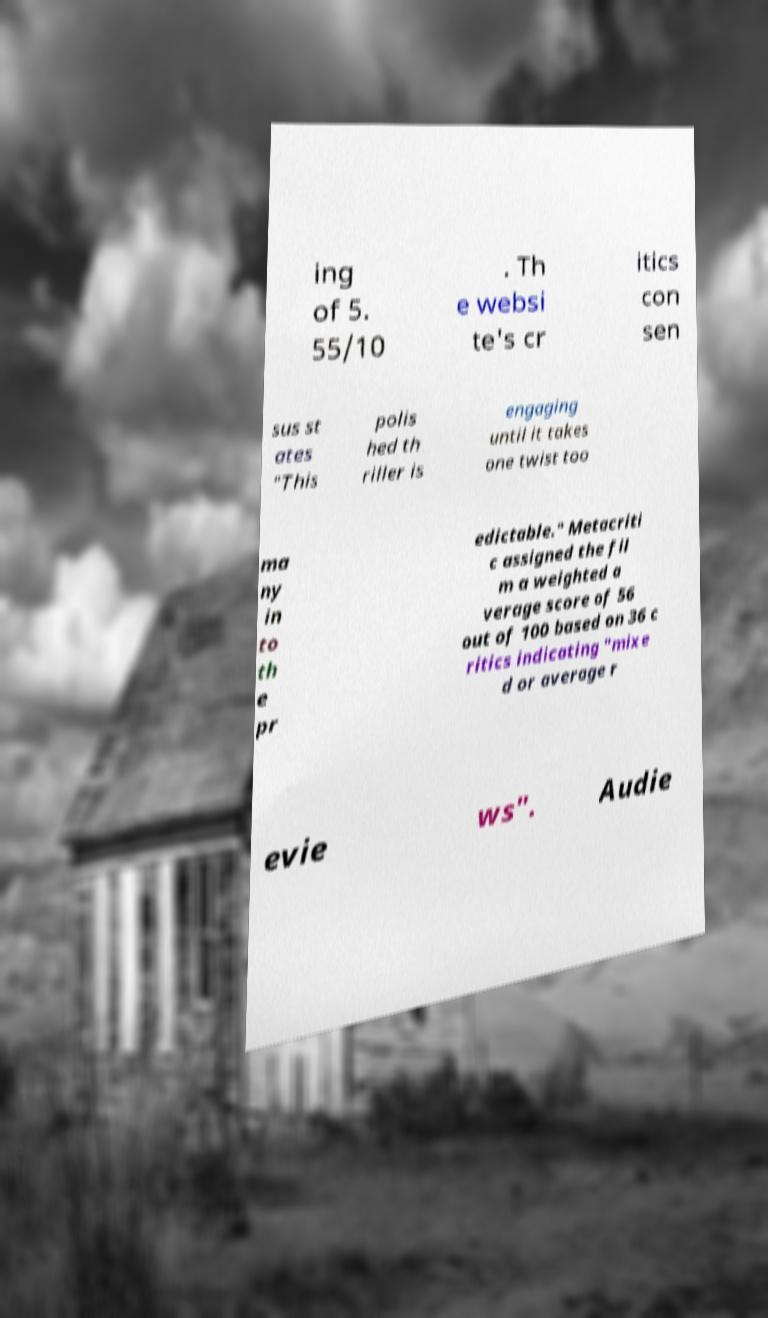There's text embedded in this image that I need extracted. Can you transcribe it verbatim? ing of 5. 55/10 . Th e websi te's cr itics con sen sus st ates "This polis hed th riller is engaging until it takes one twist too ma ny in to th e pr edictable." Metacriti c assigned the fil m a weighted a verage score of 56 out of 100 based on 36 c ritics indicating "mixe d or average r evie ws". Audie 